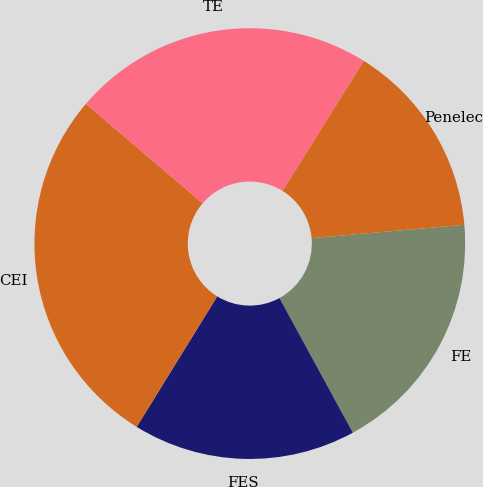<chart> <loc_0><loc_0><loc_500><loc_500><pie_chart><fcel>FE<fcel>FES<fcel>CEI<fcel>TE<fcel>Penelec<nl><fcel>18.45%<fcel>16.74%<fcel>27.44%<fcel>22.64%<fcel>14.73%<nl></chart> 